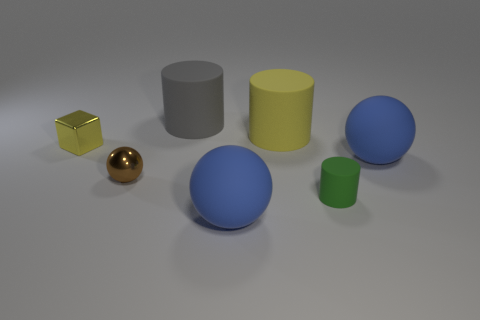Subtract all tiny metal balls. How many balls are left? 2 Subtract all brown spheres. How many spheres are left? 2 Subtract all cubes. How many objects are left? 6 Add 2 red spheres. How many objects exist? 9 Subtract 1 cylinders. How many cylinders are left? 2 Subtract all cyan cylinders. How many blue spheres are left? 2 Subtract all gray cylinders. Subtract all red balls. How many cylinders are left? 2 Subtract all big blue matte things. Subtract all brown balls. How many objects are left? 4 Add 1 yellow shiny things. How many yellow shiny things are left? 2 Add 2 small yellow shiny blocks. How many small yellow shiny blocks exist? 3 